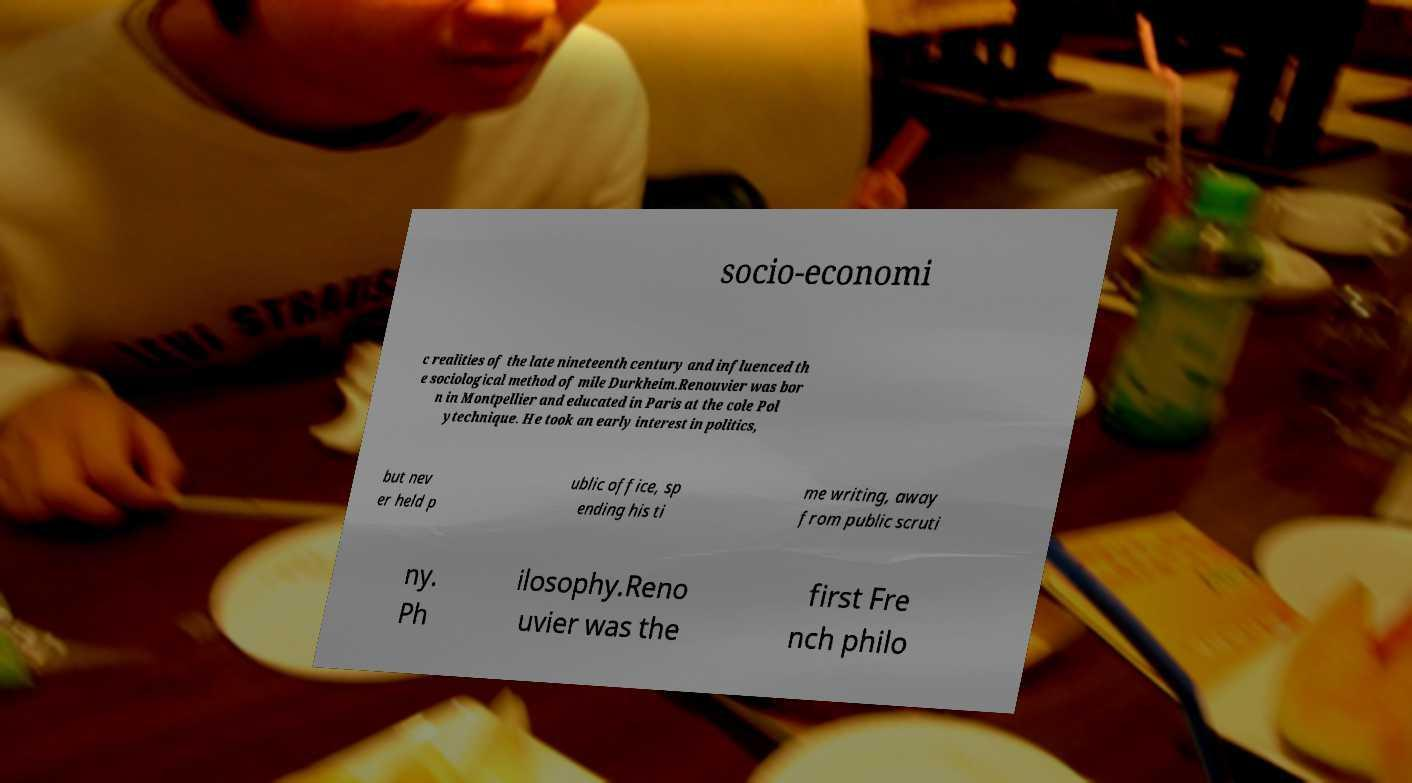I need the written content from this picture converted into text. Can you do that? socio-economi c realities of the late nineteenth century and influenced th e sociological method of mile Durkheim.Renouvier was bor n in Montpellier and educated in Paris at the cole Pol ytechnique. He took an early interest in politics, but nev er held p ublic office, sp ending his ti me writing, away from public scruti ny. Ph ilosophy.Reno uvier was the first Fre nch philo 